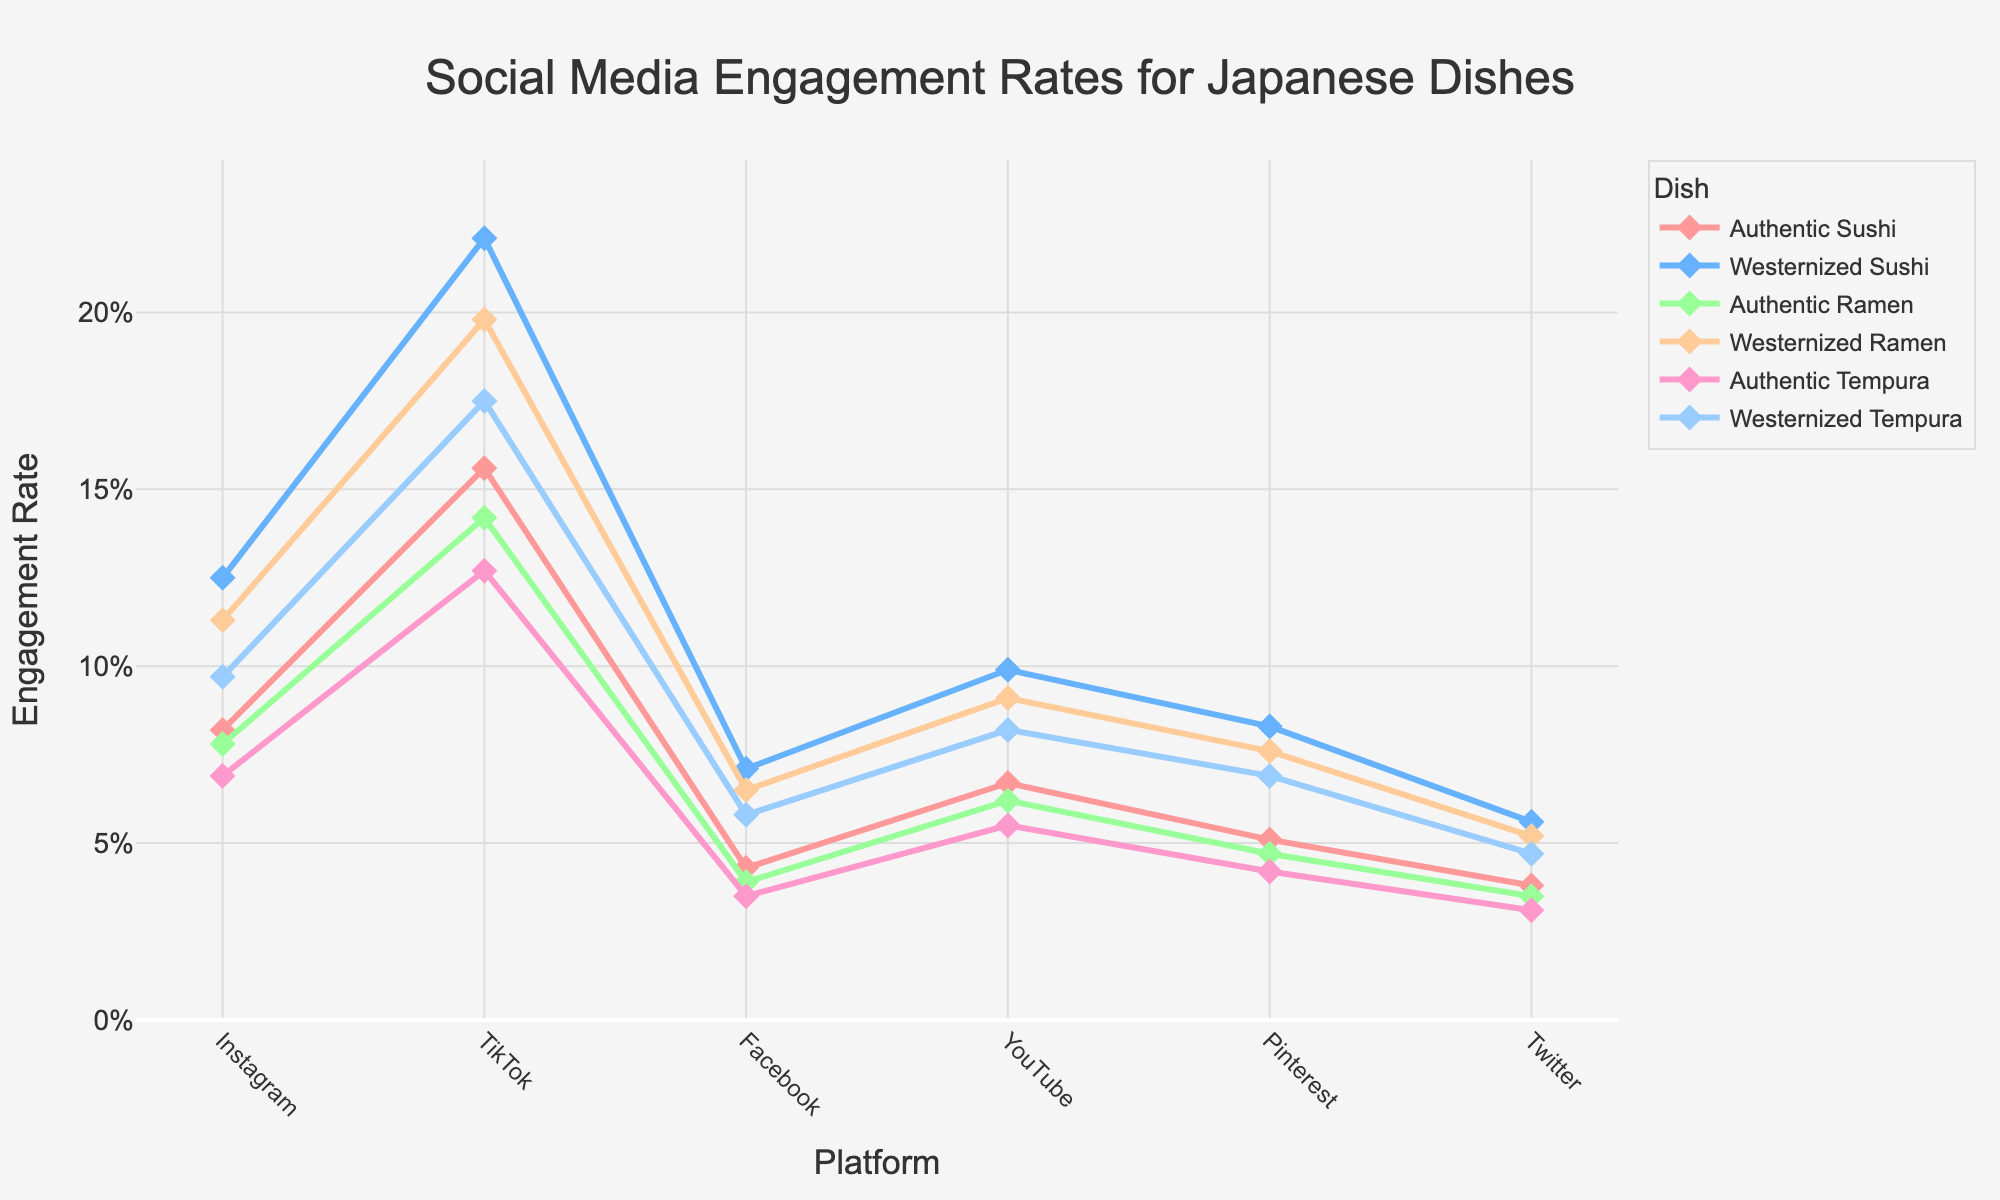Which platform has the highest engagement rate for authentic sushi? By examining the different engagement rates for authentic sushi across various platforms, TikTok shows the highest engagement rate.
Answer: TikTok Which platform has the smallest difference in engagement rate between authentic and westernized ramen? To answer this, calculate the difference in engagement rates for authentic and westernized ramen on each platform and identify the smallest. The smallest difference is on Twitter with 5.2% - 3.5% = 1.7%.
Answer: Twitter Which Japanese dish, regardless of its authenticity or westernization, gets the highest engagement on Instagram? Compare the engagement rates for all dishes on Instagram to find that Westernized Sushi has the highest engagement rate on Instagram at 12.5%.
Answer: Westernized Sushi Do all platforms have higher engagement rates for westernized tempura compared to authentic tempura? Check each platform's engagement rates for both westernized and authentic tempura to ensure that on every platform, westernized tempura has a higher rate. Upon review, this is true for Instagram (9.7% vs 6.9%), TikTok (17.5% vs 12.7%), Facebook (5.8% vs 3.5%), YouTube (8.2% vs 5.5%), Pinterest (6.9% vs 4.2%), and Twitter (4.7% vs 3.1%).
Answer: Yes What is the average engagement rate for authentic ramen across all platforms? Find the engagement rates for authentic ramen and average them: (7.8% + 14.2% + 3.9% + 6.2% + 4.7% + 3.5%) / 6 = 6.72%.
Answer: 6.72% Which platform shows the greatest disparity in engagement rates between authentic and westernized dishes overall? Calculate the absolute differences in engagement rates for each dish on every platform and find the greatest one. TikTok shows the largest disparity with 22.1% (Westernized Sushi) - 15.6% (Authentic Sushi) = 6.5%.
Answer: TikTok Which dish, either authentic or westernized, has the lowest engagement rate on Facebook? Compare the engagement rates for all dishes on Facebook and notice that Authentic Tempura has the lowest engagement rate at 3.5%.
Answer: Authentic Tempura Among all the platforms, which one has the most consistent engagement rate difference between authentic and westernized dishes when averaged across all dishes? Calculate the differences for each duo (westernized - authentic) on each platform and average those differences. The platforms show these averaged differences: Instagram (4.2%), TikTok (4.65%), Facebook (2.3%), YouTube (2.5%), Pinterest (2.8%), Twitter (1.7%). Therefore, Twitter is the most consistent.
Answer: Twitter What is the average engagement rate for westernized dishes across all platforms? Sum all westernized engagement rates: (12.5% + 11.3% + 9.7% + 22.1% + 19.8% + 17.5% + 7.1% + 6.5% + 5.8% + 9.9% + 9.1% + 8.2% + 8.3% + 7.6% + 6.9% + 5.6% + 5.2% + 4.7%) and divide by total entries 18. This equals approx 9.98%.
Answer: 9.98% Which platform has the highest overall engagement rate for any Japanese dish type presented in the data? Scan through the engagement rates for all dishes on each platform. TikTok has the highest rate with 22.1% for Westernized Sushi.
Answer: TikTok 